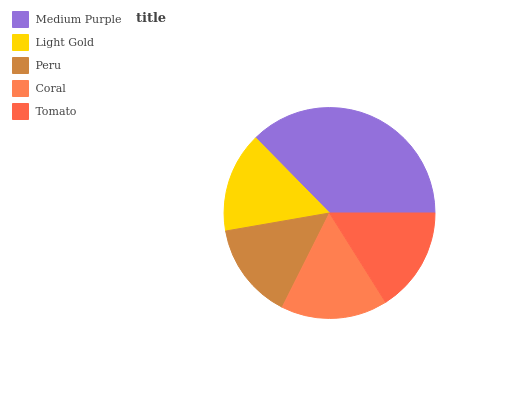Is Peru the minimum?
Answer yes or no. Yes. Is Medium Purple the maximum?
Answer yes or no. Yes. Is Light Gold the minimum?
Answer yes or no. No. Is Light Gold the maximum?
Answer yes or no. No. Is Medium Purple greater than Light Gold?
Answer yes or no. Yes. Is Light Gold less than Medium Purple?
Answer yes or no. Yes. Is Light Gold greater than Medium Purple?
Answer yes or no. No. Is Medium Purple less than Light Gold?
Answer yes or no. No. Is Tomato the high median?
Answer yes or no. Yes. Is Tomato the low median?
Answer yes or no. Yes. Is Peru the high median?
Answer yes or no. No. Is Peru the low median?
Answer yes or no. No. 